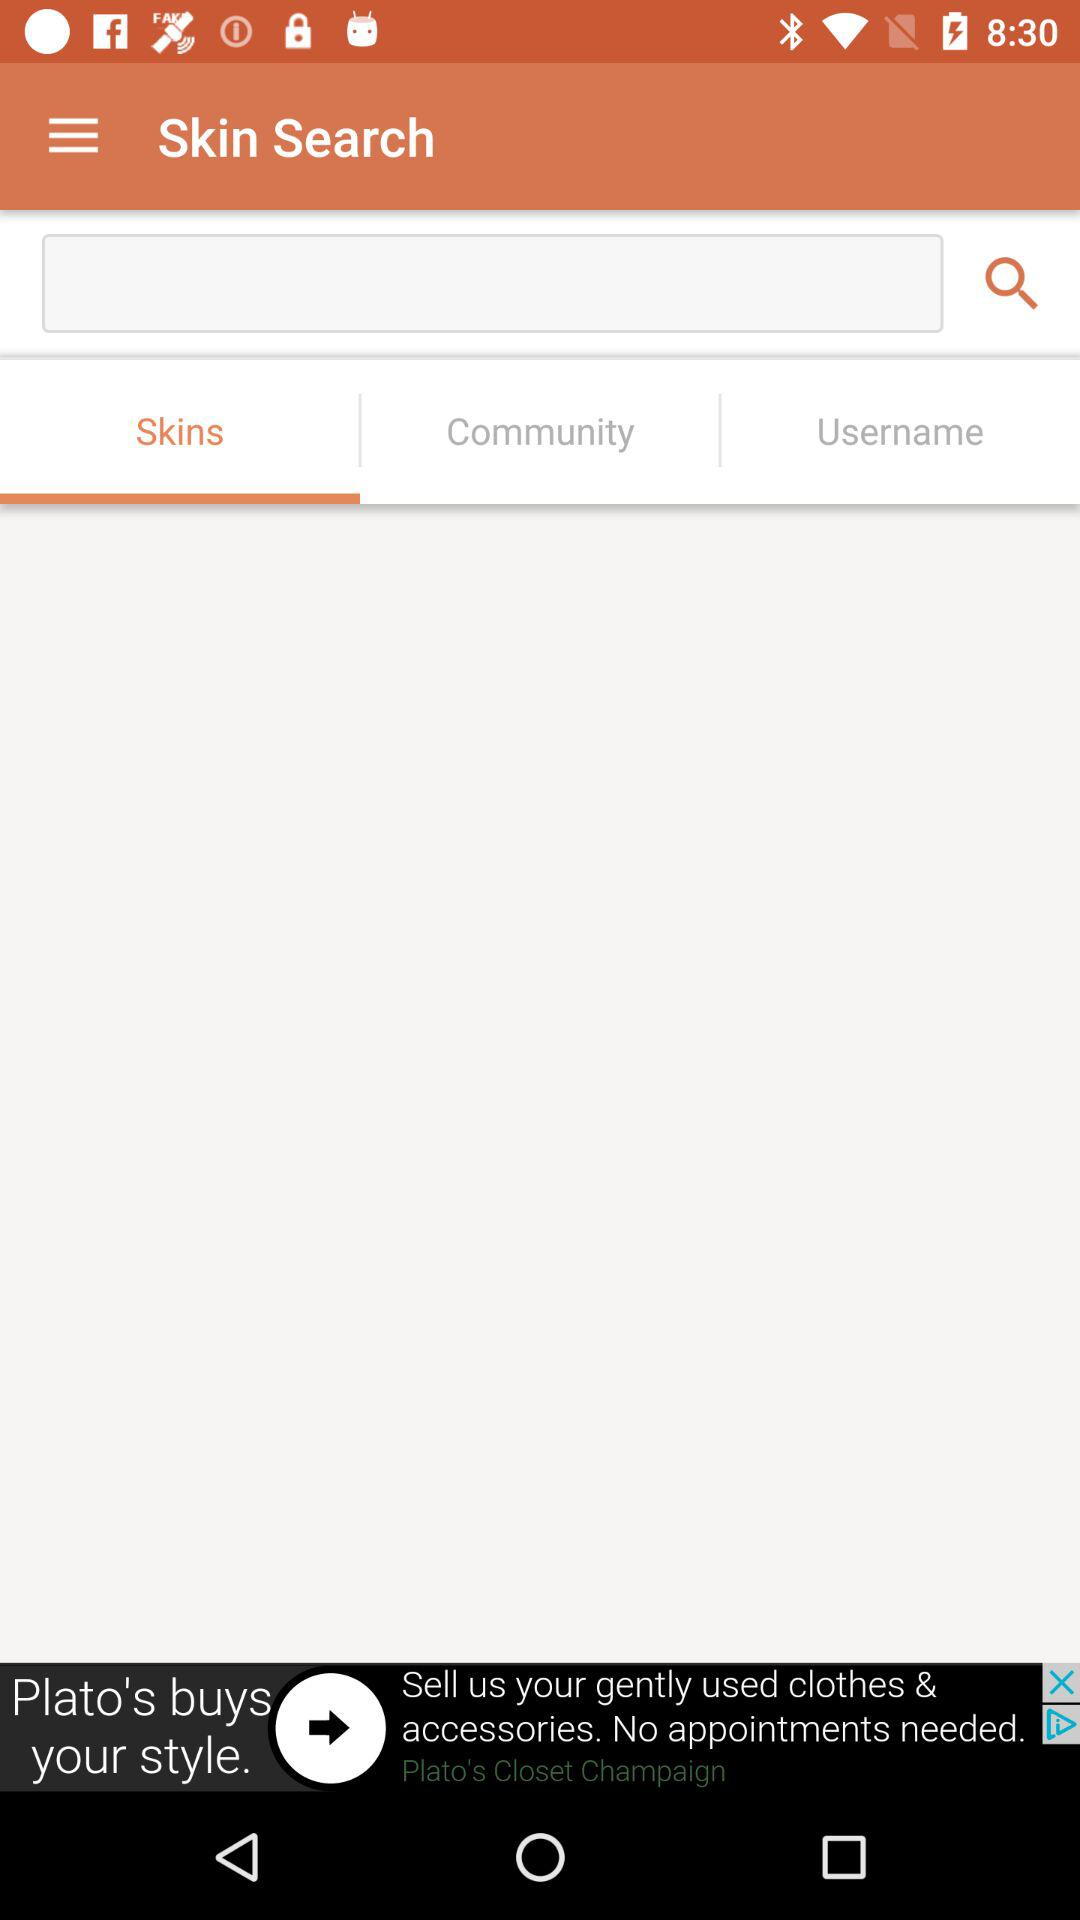Which tab has been selected? The tab "Skins" has been selected. 